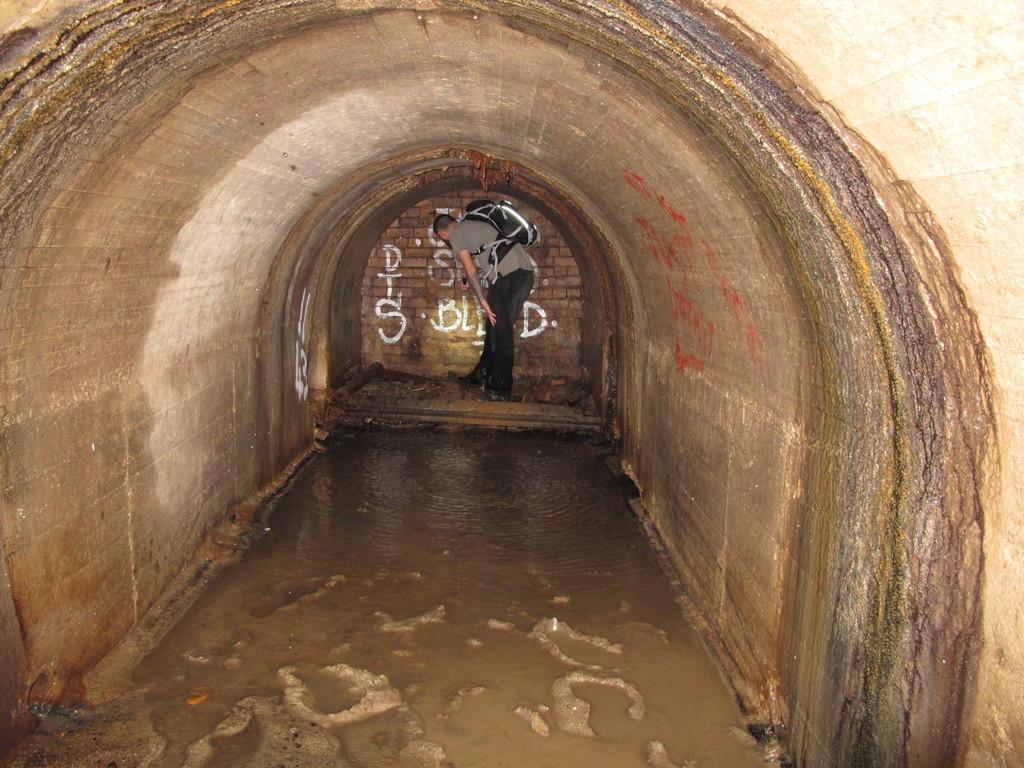Could you give a brief overview of what you see in this image? There is a tunnel. On the ground there is water. In the back there is a brick wall with something written on that. Also there is a person holding a bag. 